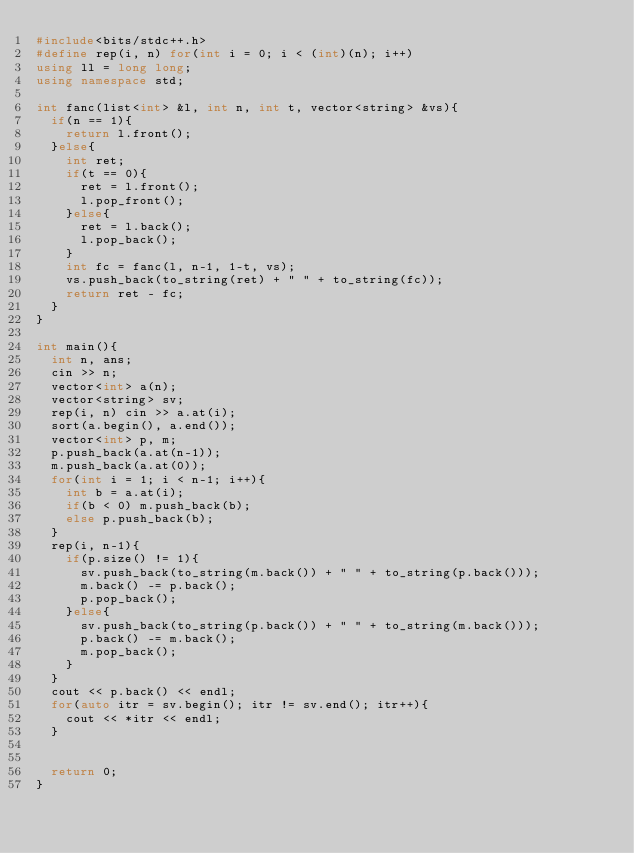<code> <loc_0><loc_0><loc_500><loc_500><_C++_>#include<bits/stdc++.h>
#define rep(i, n) for(int i = 0; i < (int)(n); i++)
using ll = long long;
using namespace std;

int fanc(list<int> &l, int n, int t, vector<string> &vs){
	if(n == 1){
		return l.front();
	}else{
		int ret;
		if(t == 0){
			ret = l.front();
			l.pop_front();
		}else{
			ret = l.back();
			l.pop_back();
		}
		int fc = fanc(l, n-1, 1-t, vs);
		vs.push_back(to_string(ret) + " " + to_string(fc));
		return ret - fc;
	}
}

int main(){
	int n, ans;
	cin >> n;
	vector<int> a(n);
	vector<string> sv;
	rep(i, n) cin >> a.at(i);
	sort(a.begin(), a.end());
	vector<int> p, m;
	p.push_back(a.at(n-1));
	m.push_back(a.at(0));
	for(int i = 1; i < n-1; i++){
		int b = a.at(i);
		if(b < 0) m.push_back(b);
		else p.push_back(b);
	}
	rep(i, n-1){
		if(p.size() != 1){
			sv.push_back(to_string(m.back()) + " " + to_string(p.back()));
			m.back() -= p.back();
			p.pop_back();
		}else{
			sv.push_back(to_string(p.back()) + " " + to_string(m.back()));
			p.back() -= m.back();
			m.pop_back();
		}
	}
	cout << p.back() << endl;
	for(auto itr = sv.begin(); itr != sv.end(); itr++){
		cout << *itr << endl;
	}
	
	
	return 0;
}</code> 